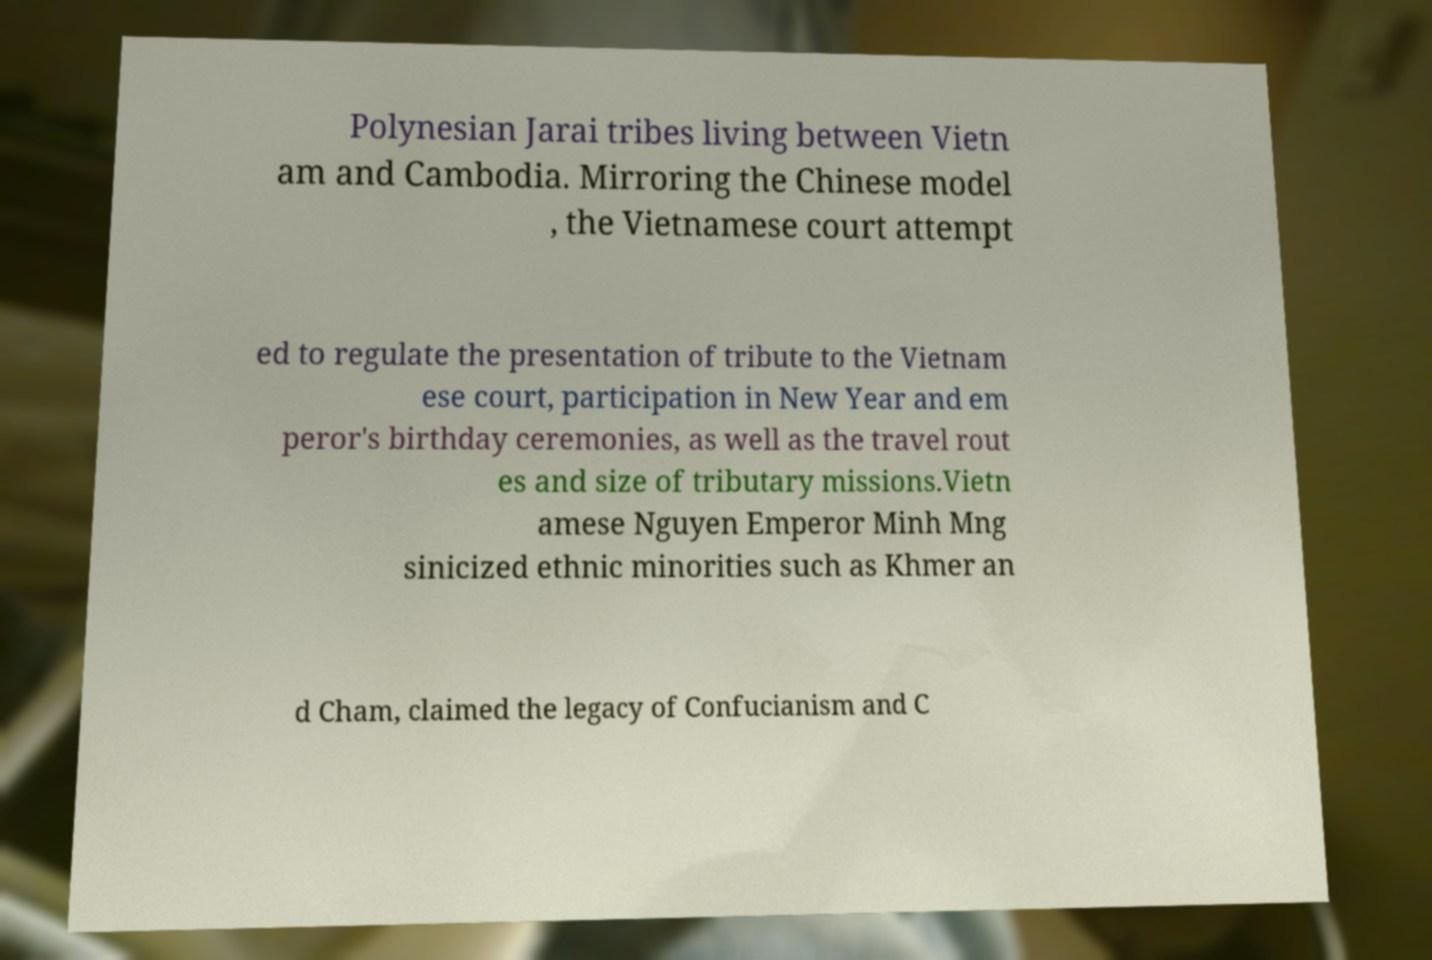Please identify and transcribe the text found in this image. Polynesian Jarai tribes living between Vietn am and Cambodia. Mirroring the Chinese model , the Vietnamese court attempt ed to regulate the presentation of tribute to the Vietnam ese court, participation in New Year and em peror's birthday ceremonies, as well as the travel rout es and size of tributary missions.Vietn amese Nguyen Emperor Minh Mng sinicized ethnic minorities such as Khmer an d Cham, claimed the legacy of Confucianism and C 